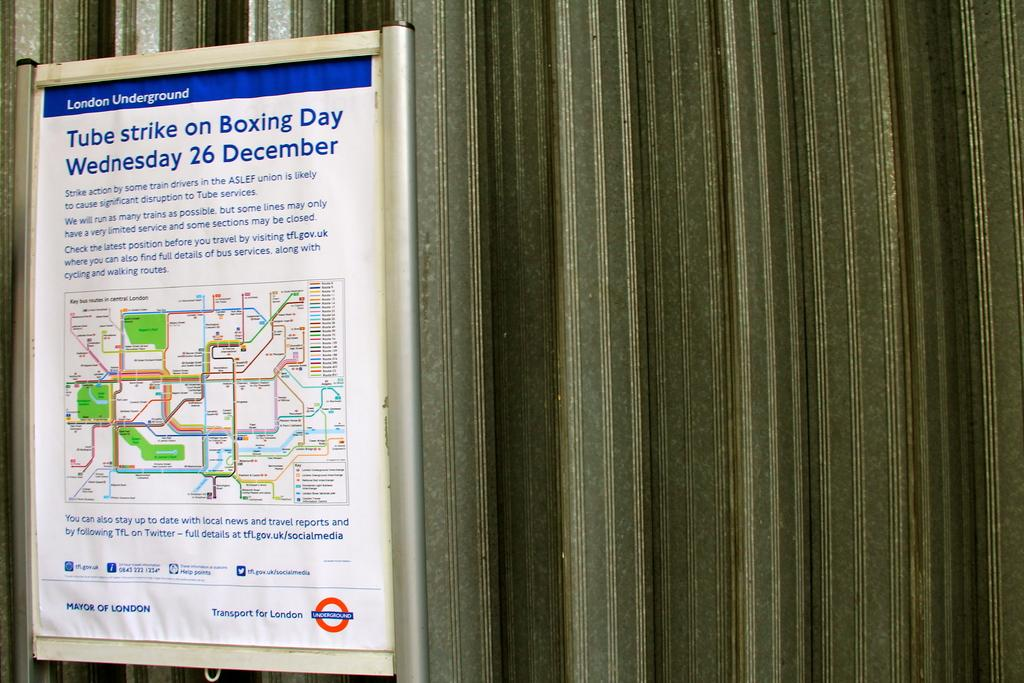Provide a one-sentence caption for the provided image. A sign regarding the Tube strike on Boxing Day. 